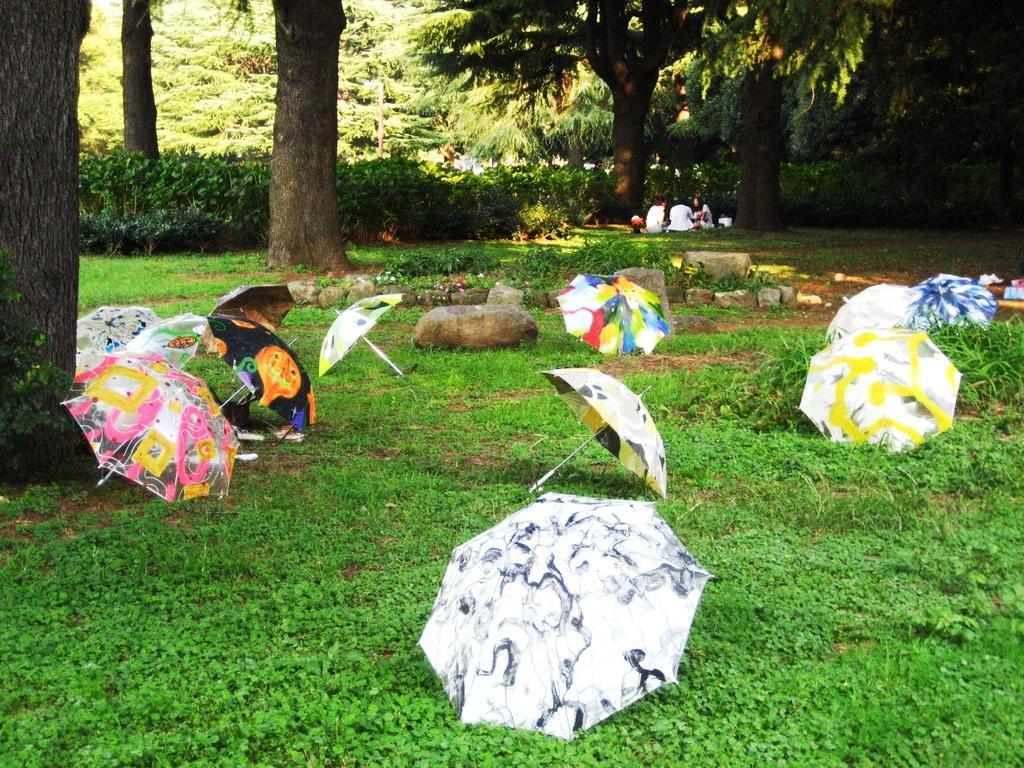Describe this image in one or two sentences. In this image, at the bottom there are umbrellas, stones, plants, flowers, grass. In the middle there are people, trees, plants. 